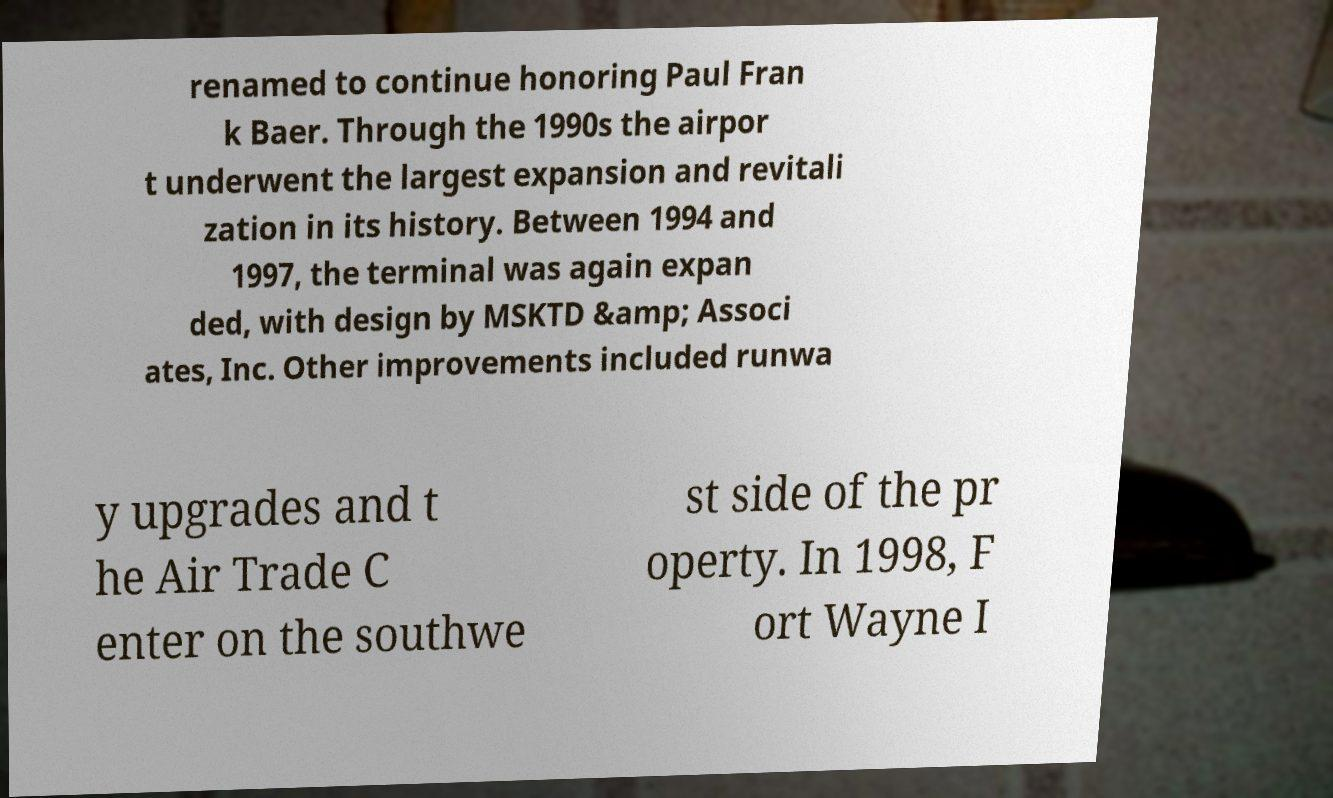There's text embedded in this image that I need extracted. Can you transcribe it verbatim? renamed to continue honoring Paul Fran k Baer. Through the 1990s the airpor t underwent the largest expansion and revitali zation in its history. Between 1994 and 1997, the terminal was again expan ded, with design by MSKTD &amp; Associ ates, Inc. Other improvements included runwa y upgrades and t he Air Trade C enter on the southwe st side of the pr operty. In 1998, F ort Wayne I 